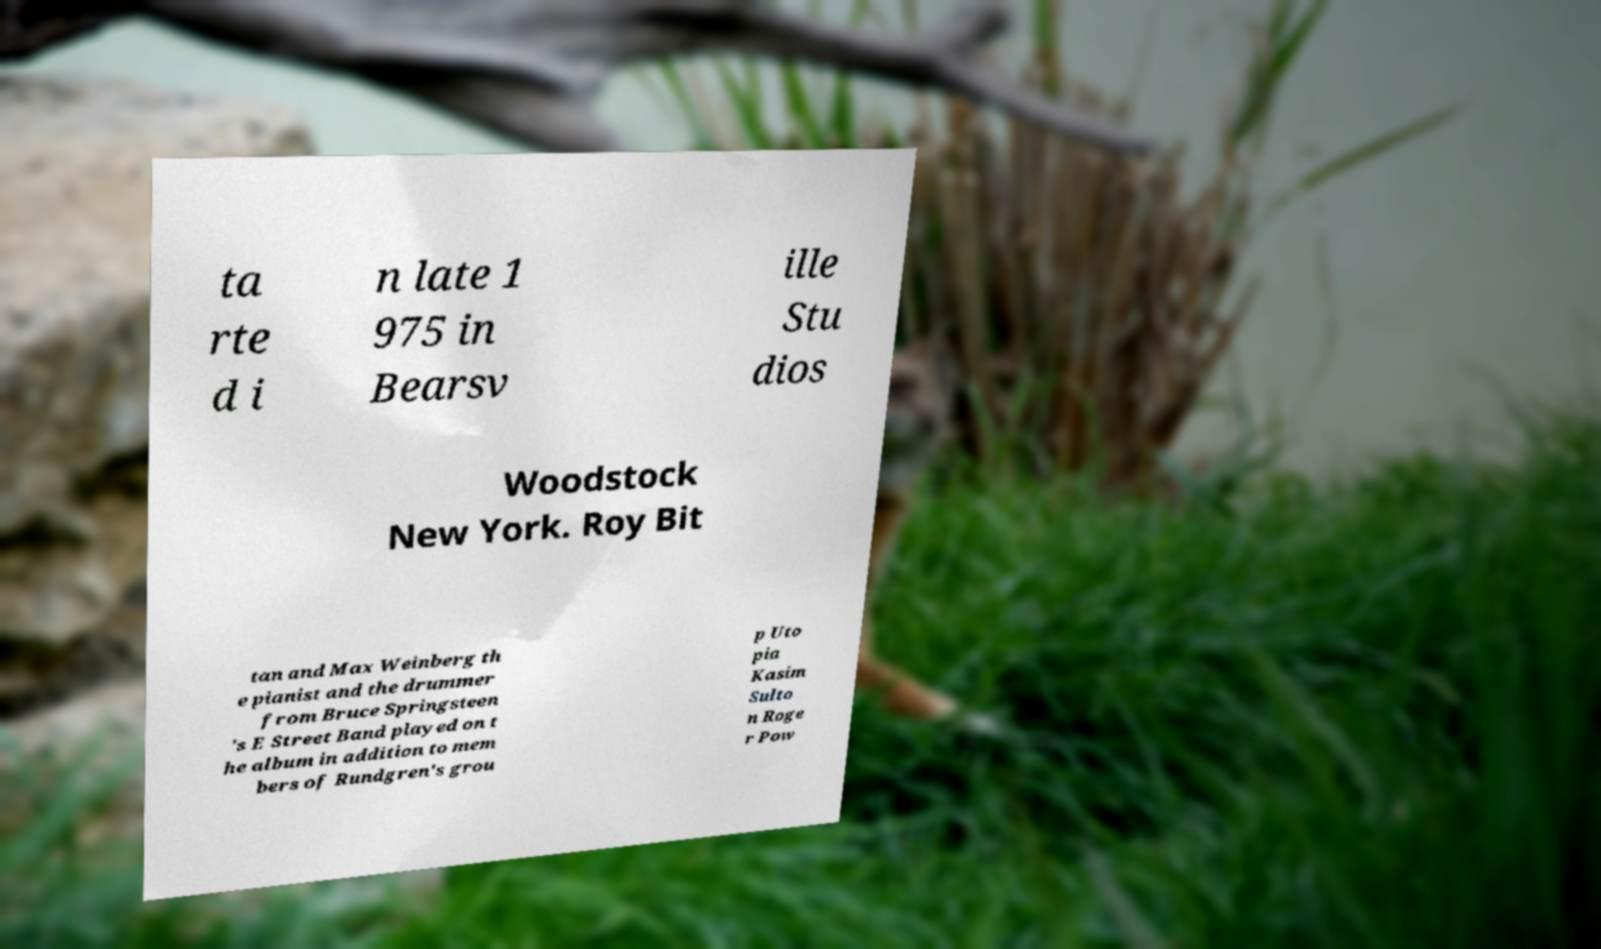Could you extract and type out the text from this image? ta rte d i n late 1 975 in Bearsv ille Stu dios Woodstock New York. Roy Bit tan and Max Weinberg th e pianist and the drummer from Bruce Springsteen 's E Street Band played on t he album in addition to mem bers of Rundgren's grou p Uto pia Kasim Sulto n Roge r Pow 